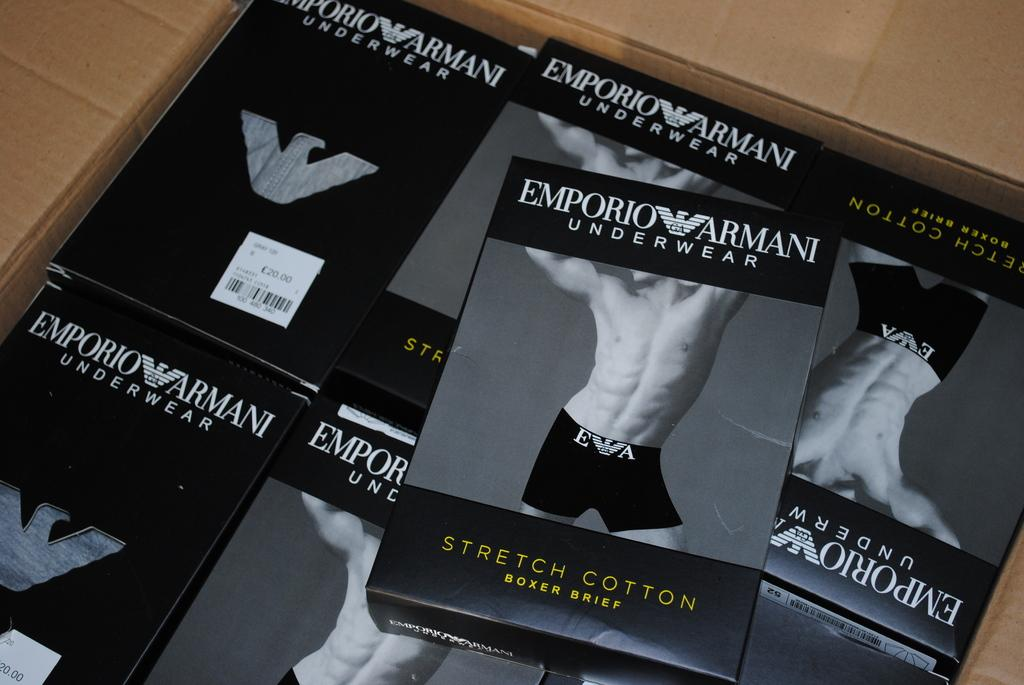<image>
Render a clear and concise summary of the photo. A bunch of packages of underwear of the brand Emporium Armani. 